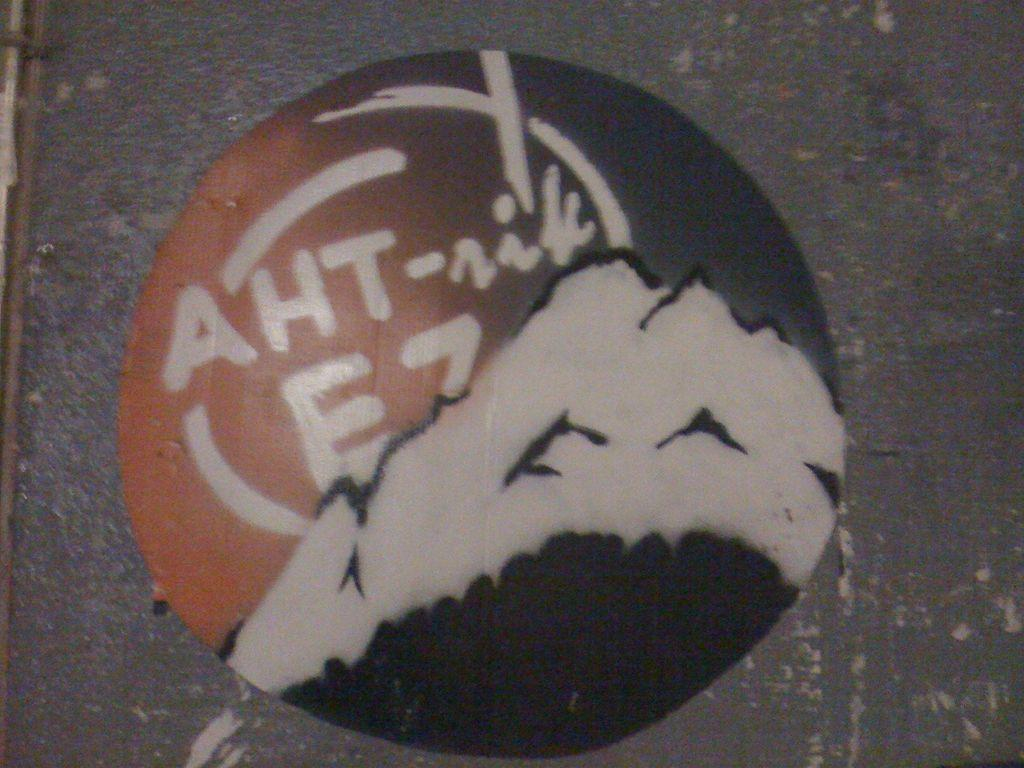What is on the wall in the image? There is a painting on the wall in the image. Are there any plants growing on the slope in the image? There is no slope or plants mentioned in the image; it only features a painting on the wall. 